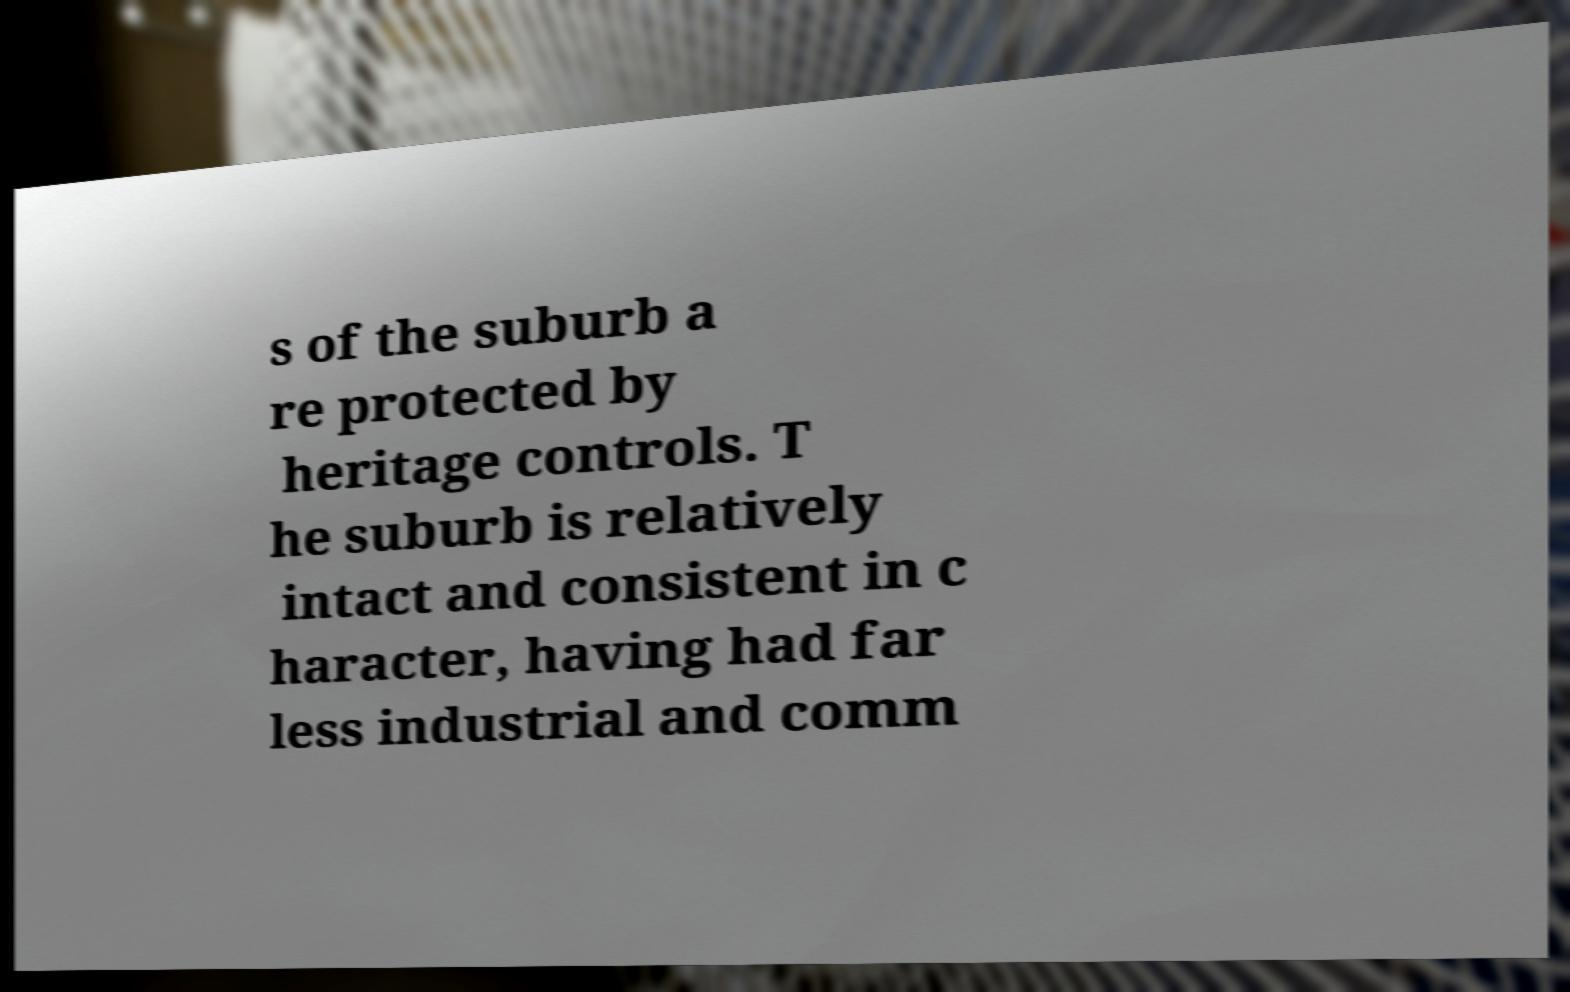Could you assist in decoding the text presented in this image and type it out clearly? s of the suburb a re protected by heritage controls. T he suburb is relatively intact and consistent in c haracter, having had far less industrial and comm 